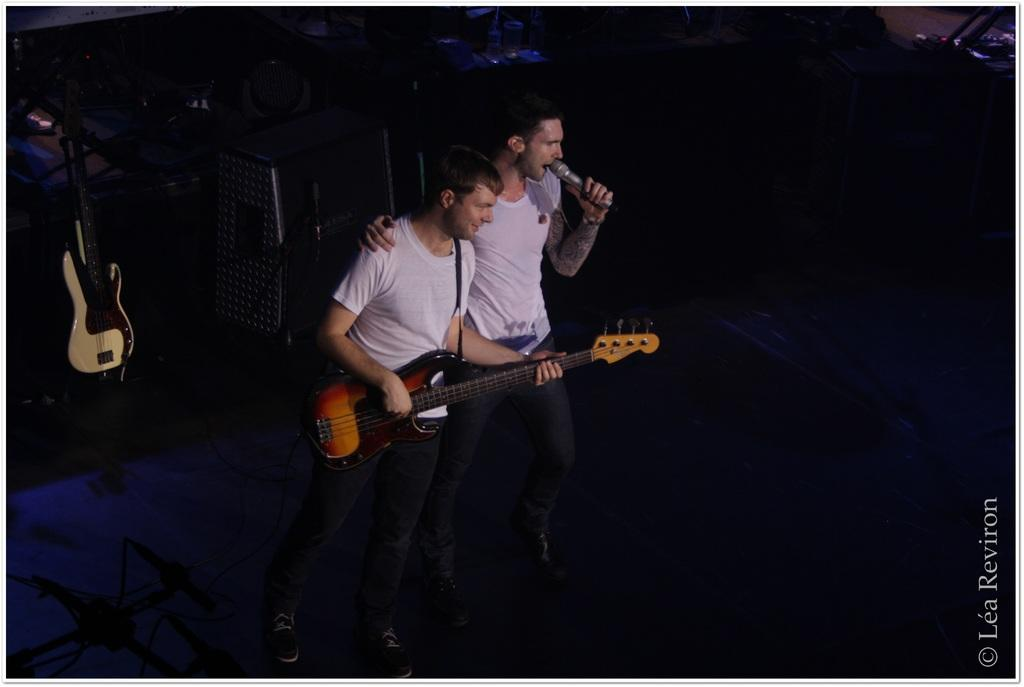How many people are in the image? There are two men in the image. What are the men doing in the image? The man on the right is signing on a mic, and the man on the left is playing a guitar. Can you describe the objects in the image? There is a guitar on the left side of the image. Is there a bomb visible in the image? No, there is no bomb present in the image. Are the two men in the image fighting? No, the two men are not fighting; they are engaged in musical activities. 